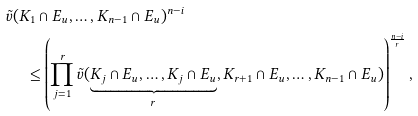<formula> <loc_0><loc_0><loc_500><loc_500>& \tilde { v } ( K _ { 1 } \cap E _ { u } , \dots , K _ { n - 1 } \cap E _ { u } ) ^ { n - i } \\ & \quad \, \leq \left ( \prod _ { j = 1 } ^ { r } \tilde { v } ( \underbrace { K _ { j } \cap E _ { u } , \dots , K _ { j } \cap E _ { u } } _ { r } , K _ { r + 1 } \cap E _ { u } , \dots , K _ { n - 1 } \cap E _ { u } ) \right ) ^ { \frac { n - i } { r } } ,</formula> 